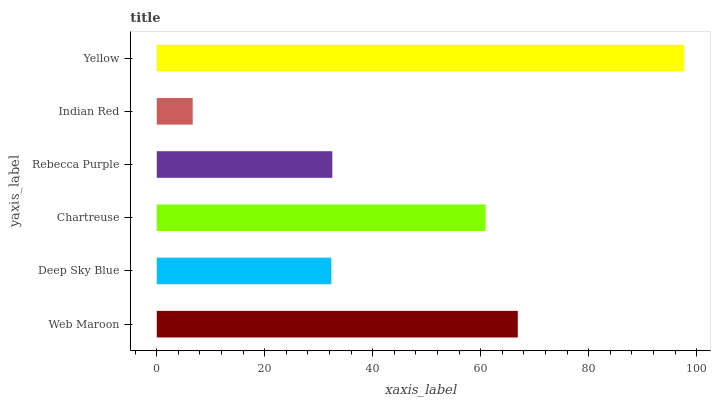Is Indian Red the minimum?
Answer yes or no. Yes. Is Yellow the maximum?
Answer yes or no. Yes. Is Deep Sky Blue the minimum?
Answer yes or no. No. Is Deep Sky Blue the maximum?
Answer yes or no. No. Is Web Maroon greater than Deep Sky Blue?
Answer yes or no. Yes. Is Deep Sky Blue less than Web Maroon?
Answer yes or no. Yes. Is Deep Sky Blue greater than Web Maroon?
Answer yes or no. No. Is Web Maroon less than Deep Sky Blue?
Answer yes or no. No. Is Chartreuse the high median?
Answer yes or no. Yes. Is Rebecca Purple the low median?
Answer yes or no. Yes. Is Rebecca Purple the high median?
Answer yes or no. No. Is Deep Sky Blue the low median?
Answer yes or no. No. 